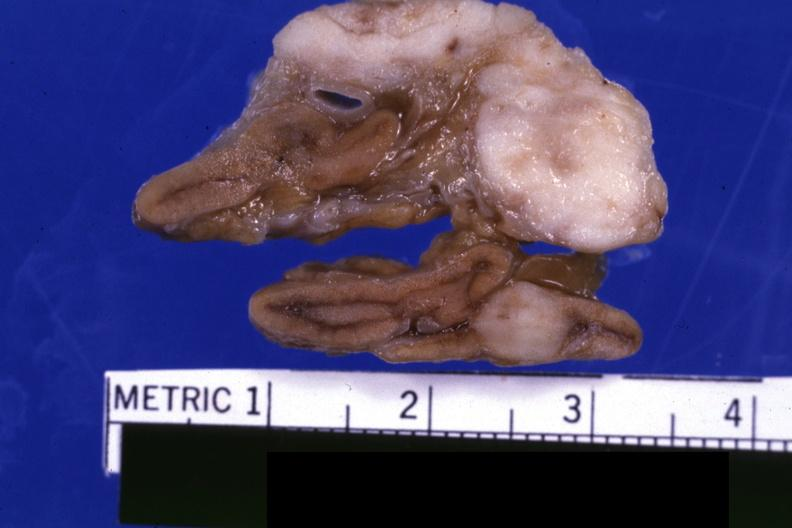s endocrine present?
Answer the question using a single word or phrase. Yes 